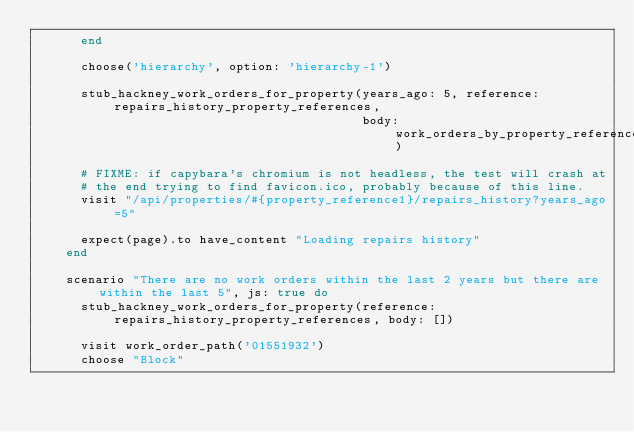<code> <loc_0><loc_0><loc_500><loc_500><_Ruby_>      end

      choose('hierarchy', option: 'hierarchy-1')

      stub_hackney_work_orders_for_property(years_ago: 5, reference: repairs_history_property_references,
                                            body: work_orders_by_property_reference_payload)

      # FIXME: if capybara's chromium is not headless, the test will crash at
      # the end trying to find favicon.ico, probably because of this line.
      visit "/api/properties/#{property_reference1}/repairs_history?years_ago=5"

      expect(page).to have_content "Loading repairs history"
    end

    scenario "There are no work orders within the last 2 years but there are within the last 5", js: true do
      stub_hackney_work_orders_for_property(reference: repairs_history_property_references, body: [])

      visit work_order_path('01551932')
      choose "Block"</code> 